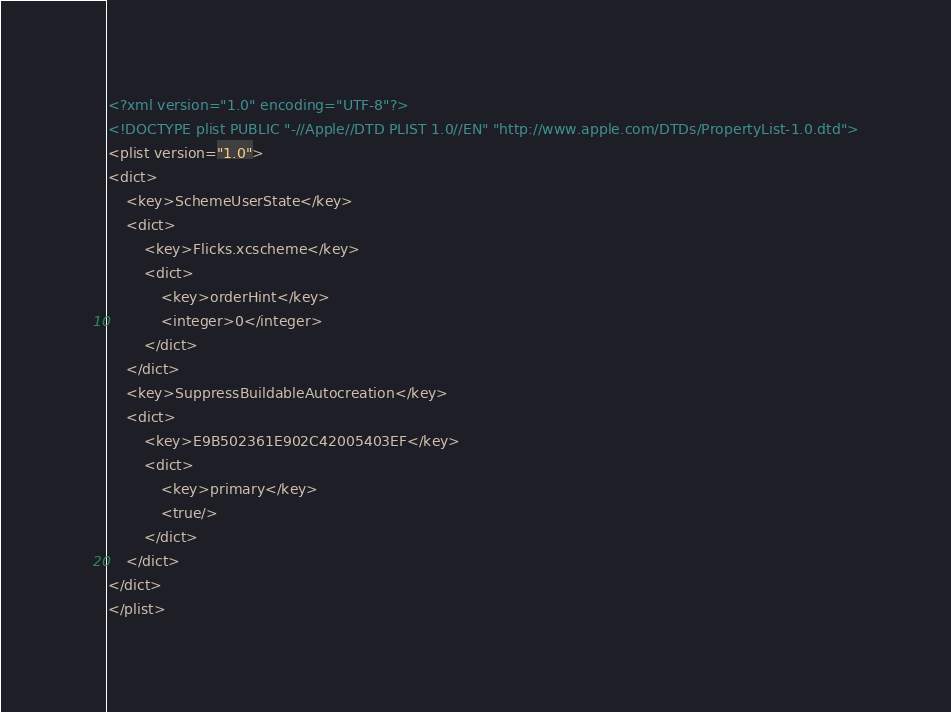Convert code to text. <code><loc_0><loc_0><loc_500><loc_500><_XML_><?xml version="1.0" encoding="UTF-8"?>
<!DOCTYPE plist PUBLIC "-//Apple//DTD PLIST 1.0//EN" "http://www.apple.com/DTDs/PropertyList-1.0.dtd">
<plist version="1.0">
<dict>
	<key>SchemeUserState</key>
	<dict>
		<key>Flicks.xcscheme</key>
		<dict>
			<key>orderHint</key>
			<integer>0</integer>
		</dict>
	</dict>
	<key>SuppressBuildableAutocreation</key>
	<dict>
		<key>E9B502361E902C42005403EF</key>
		<dict>
			<key>primary</key>
			<true/>
		</dict>
	</dict>
</dict>
</plist>
</code> 